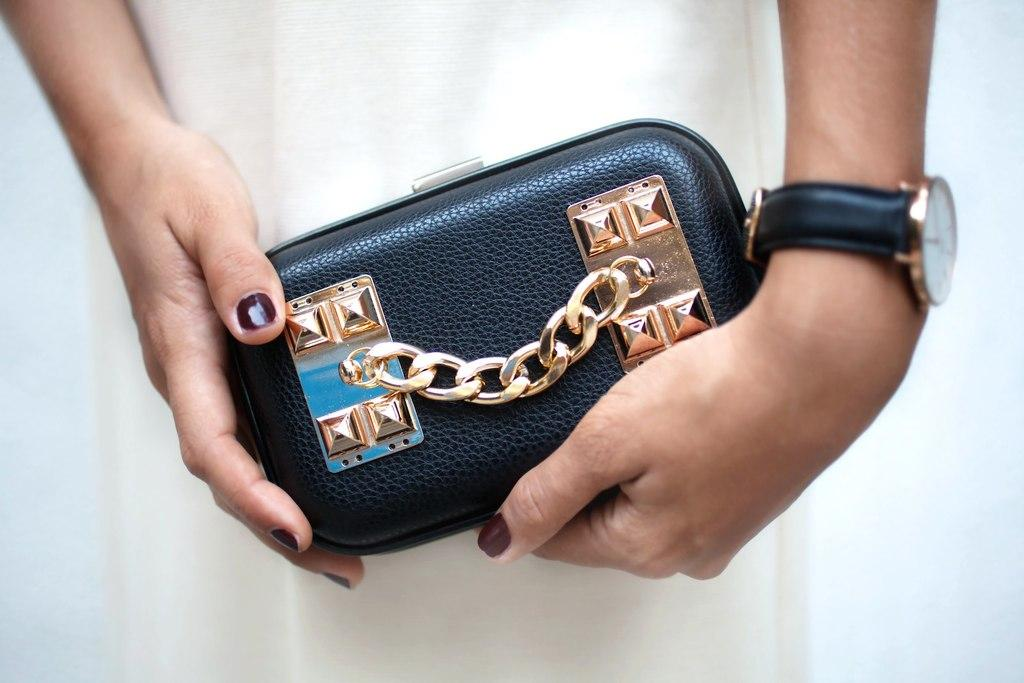Who is the main subject in the image? There is a lady in the image. What is the lady wearing? The lady is wearing a white dress. What is the lady holding in the image? The lady is holding a black box. Are there any additional features on the black box? Yes, there is a gold chain attached to the black box. What accessory is the lady wearing on her left hand? The lady is wearing a black watch on her left hand. Can you tell me where the trail leading to the zoo is located in the image? There is no trail or zoo present in the image; it features a lady holding a black box with a gold chain attached to it. What type of cannon is visible in the image? There is no cannon present in the image. 